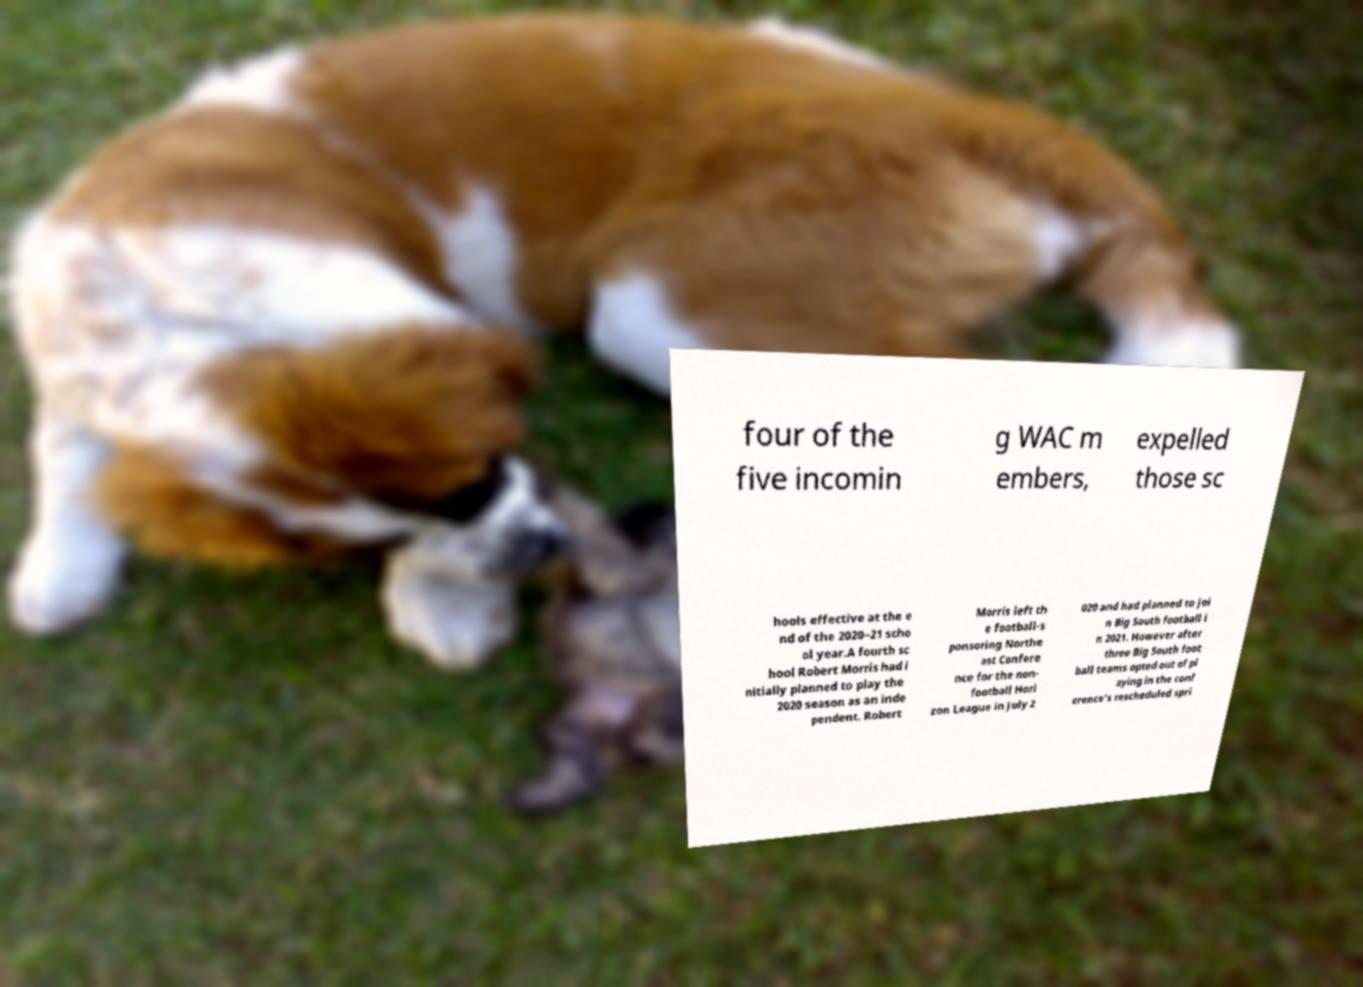Please identify and transcribe the text found in this image. four of the five incomin g WAC m embers, expelled those sc hools effective at the e nd of the 2020–21 scho ol year.A fourth sc hool Robert Morris had i nitially planned to play the 2020 season as an inde pendent. Robert Morris left th e football-s ponsoring Northe ast Confere nce for the non- football Hori zon League in July 2 020 and had planned to joi n Big South football i n 2021. However after three Big South foot ball teams opted out of pl aying in the conf erence's rescheduled spri 